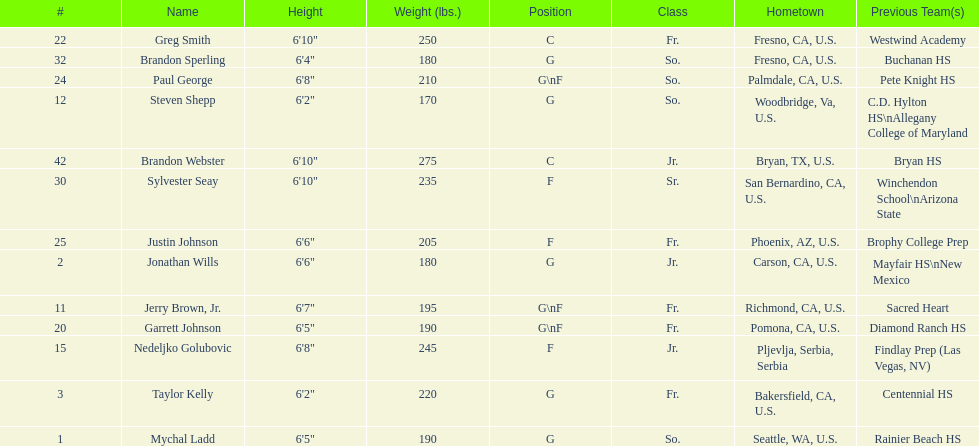Which player previously played for sacred heart? Jerry Brown, Jr. 